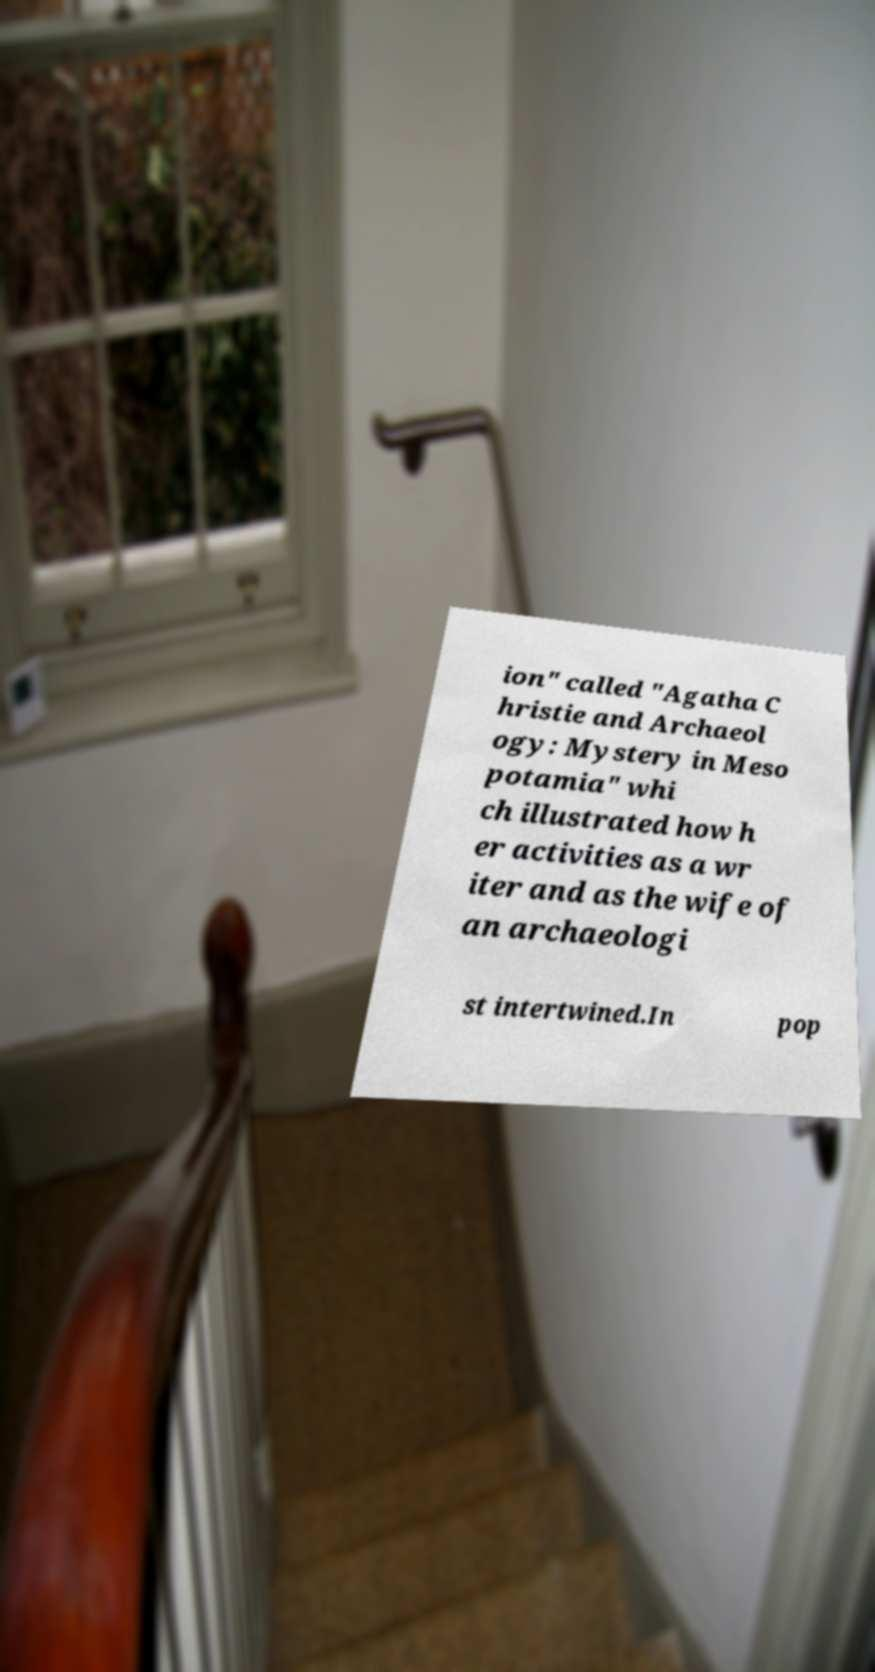Could you assist in decoding the text presented in this image and type it out clearly? ion" called "Agatha C hristie and Archaeol ogy: Mystery in Meso potamia" whi ch illustrated how h er activities as a wr iter and as the wife of an archaeologi st intertwined.In pop 